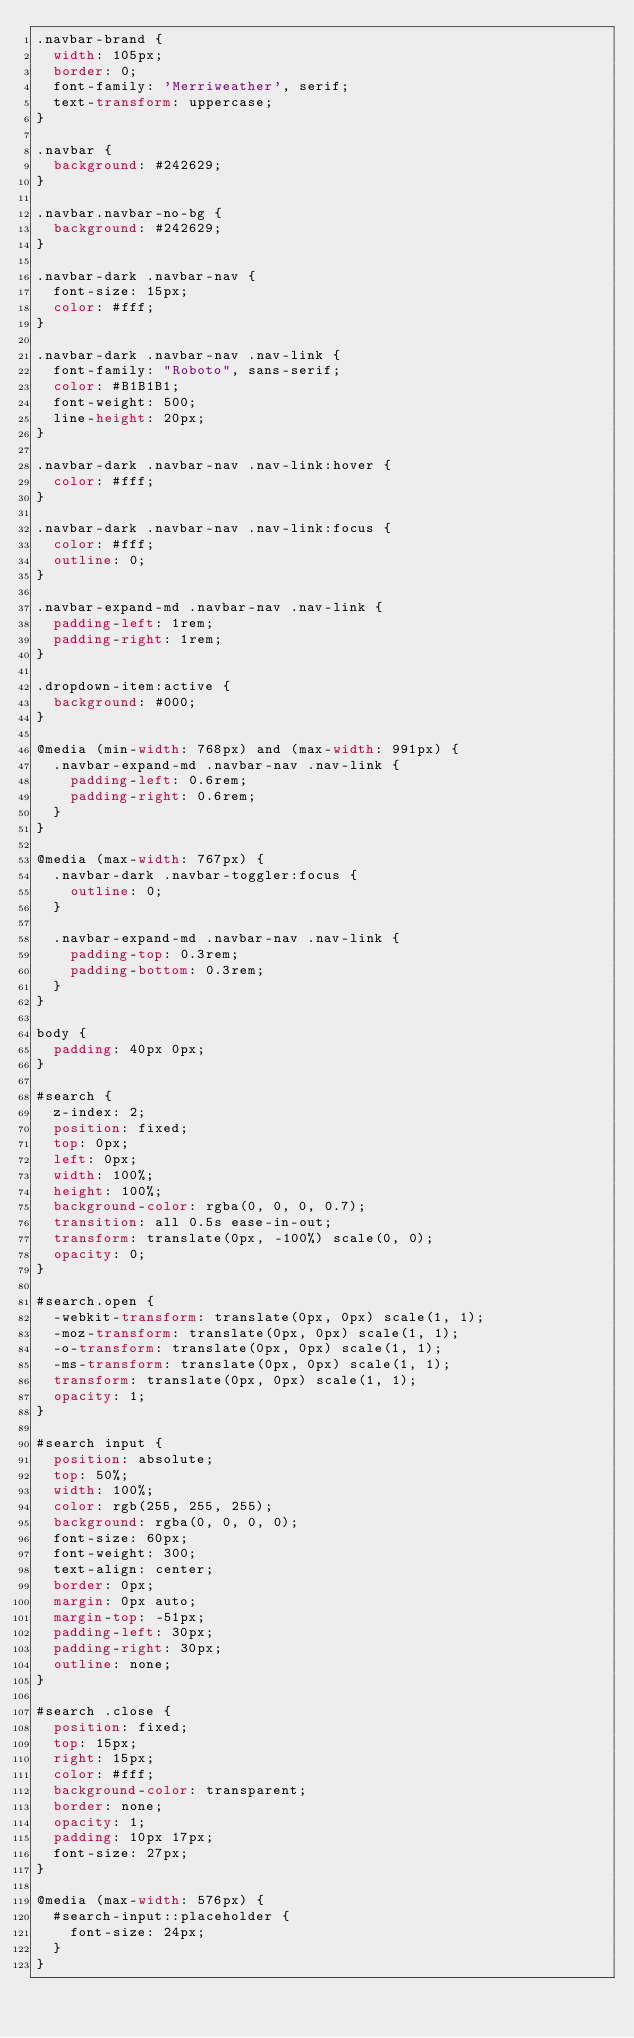<code> <loc_0><loc_0><loc_500><loc_500><_CSS_>.navbar-brand {
  width: 105px;
  border: 0;
  font-family: 'Merriweather', serif;
  text-transform: uppercase;
}

.navbar {
  background: #242629;
}

.navbar.navbar-no-bg {
  background: #242629;
}

.navbar-dark .navbar-nav {
  font-size: 15px;
  color: #fff;
}

.navbar-dark .navbar-nav .nav-link {
  font-family: "Roboto", sans-serif;
  color: #B1B1B1;
  font-weight: 500;
  line-height: 20px;
}

.navbar-dark .navbar-nav .nav-link:hover {
  color: #fff;
}

.navbar-dark .navbar-nav .nav-link:focus {
  color: #fff;
  outline: 0;
}

.navbar-expand-md .navbar-nav .nav-link {
  padding-left: 1rem;
  padding-right: 1rem;
}

.dropdown-item:active {
  background: #000;
}

@media (min-width: 768px) and (max-width: 991px) {
  .navbar-expand-md .navbar-nav .nav-link {
    padding-left: 0.6rem;
    padding-right: 0.6rem;
  }
}

@media (max-width: 767px) {
  .navbar-dark .navbar-toggler:focus {
    outline: 0;
  }

  .navbar-expand-md .navbar-nav .nav-link {
    padding-top: 0.3rem;
    padding-bottom: 0.3rem;
  }
}

body {
  padding: 40px 0px;
}

#search {
  z-index: 2;
  position: fixed;
  top: 0px;
  left: 0px;
  width: 100%;
  height: 100%;
  background-color: rgba(0, 0, 0, 0.7);
  transition: all 0.5s ease-in-out;
  transform: translate(0px, -100%) scale(0, 0);
  opacity: 0;
}

#search.open {
  -webkit-transform: translate(0px, 0px) scale(1, 1);
  -moz-transform: translate(0px, 0px) scale(1, 1);
  -o-transform: translate(0px, 0px) scale(1, 1);
  -ms-transform: translate(0px, 0px) scale(1, 1);
  transform: translate(0px, 0px) scale(1, 1);
  opacity: 1;
}

#search input {
  position: absolute;
  top: 50%;
  width: 100%;
  color: rgb(255, 255, 255);
  background: rgba(0, 0, 0, 0);
  font-size: 60px;
  font-weight: 300;
  text-align: center;
  border: 0px;
  margin: 0px auto;
  margin-top: -51px;
  padding-left: 30px;
  padding-right: 30px;
  outline: none;
}

#search .close {
  position: fixed;
  top: 15px;
  right: 15px;
  color: #fff;
  background-color: transparent;
  border: none;
  opacity: 1;
  padding: 10px 17px;
  font-size: 27px;
}

@media (max-width: 576px) {
  #search-input::placeholder {
    font-size: 24px;
  }
}
</code> 